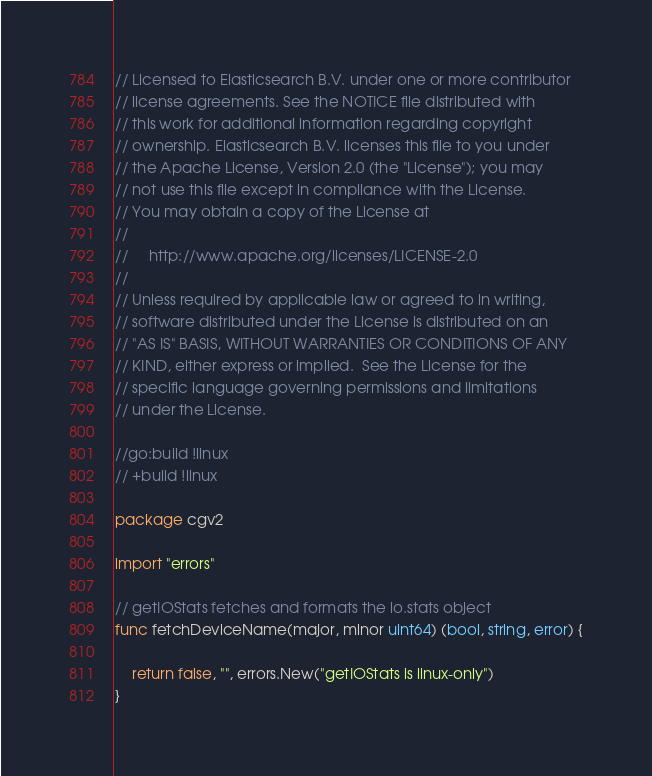<code> <loc_0><loc_0><loc_500><loc_500><_Go_>// Licensed to Elasticsearch B.V. under one or more contributor
// license agreements. See the NOTICE file distributed with
// this work for additional information regarding copyright
// ownership. Elasticsearch B.V. licenses this file to you under
// the Apache License, Version 2.0 (the "License"); you may
// not use this file except in compliance with the License.
// You may obtain a copy of the License at
//
//     http://www.apache.org/licenses/LICENSE-2.0
//
// Unless required by applicable law or agreed to in writing,
// software distributed under the License is distributed on an
// "AS IS" BASIS, WITHOUT WARRANTIES OR CONDITIONS OF ANY
// KIND, either express or implied.  See the License for the
// specific language governing permissions and limitations
// under the License.

//go:build !linux
// +build !linux

package cgv2

import "errors"

// getIOStats fetches and formats the io.stats object
func fetchDeviceName(major, minor uint64) (bool, string, error) {

	return false, "", errors.New("getIOStats is linux-only")
}
</code> 